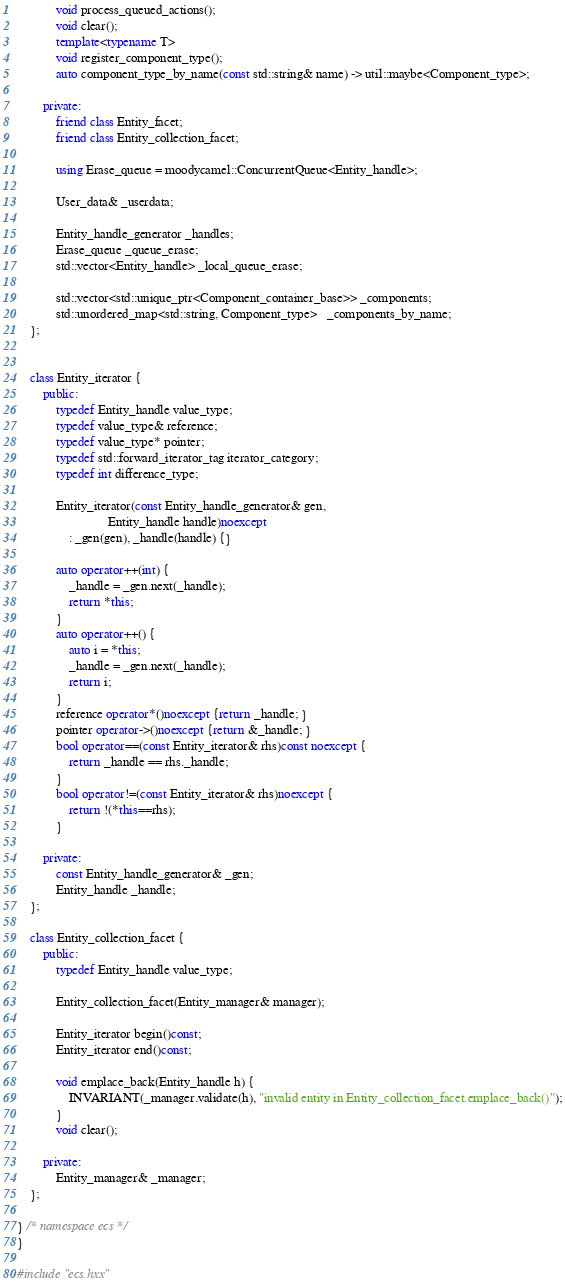Convert code to text. <code><loc_0><loc_0><loc_500><loc_500><_C++_>			void process_queued_actions();
			void clear();
			template<typename T>
			void register_component_type();
			auto component_type_by_name(const std::string& name) -> util::maybe<Component_type>;

		private:
			friend class Entity_facet;
			friend class Entity_collection_facet;

			using Erase_queue = moodycamel::ConcurrentQueue<Entity_handle>;

			User_data& _userdata;

			Entity_handle_generator _handles;
			Erase_queue _queue_erase;
			std::vector<Entity_handle> _local_queue_erase;

			std::vector<std::unique_ptr<Component_container_base>> _components;
			std::unordered_map<std::string, Component_type>   _components_by_name;
	};
	
	
	class Entity_iterator {
		public:
			typedef Entity_handle value_type;
			typedef value_type& reference;
			typedef value_type* pointer;
			typedef std::forward_iterator_tag iterator_category;
			typedef int difference_type;
			
			Entity_iterator(const Entity_handle_generator& gen,
			                Entity_handle handle)noexcept
			    : _gen(gen), _handle(handle) {}
			
			auto operator++(int) {
				_handle = _gen.next(_handle);
				return *this;
			}
			auto operator++() {
				auto i = *this;
				_handle = _gen.next(_handle);
				return i;
			}
			reference operator*()noexcept {return _handle; }
			pointer operator->()noexcept {return &_handle; }
			bool operator==(const Entity_iterator& rhs)const noexcept {
				return _handle == rhs._handle;
			}
			bool operator!=(const Entity_iterator& rhs)noexcept {
				return !(*this==rhs);
			}
			
		private:
			const Entity_handle_generator& _gen;
			Entity_handle _handle;
	};
	
	class Entity_collection_facet {
		public:
			typedef Entity_handle value_type;

			Entity_collection_facet(Entity_manager& manager);
			
			Entity_iterator begin()const;
			Entity_iterator end()const;
			
			void emplace_back(Entity_handle h) {
				INVARIANT(_manager.validate(h), "invalid entity in Entity_collection_facet.emplace_back()");
			}
			void clear();
			
		private:
			Entity_manager& _manager;
	};

} /* namespace ecs */
}

#include "ecs.hxx"

</code> 